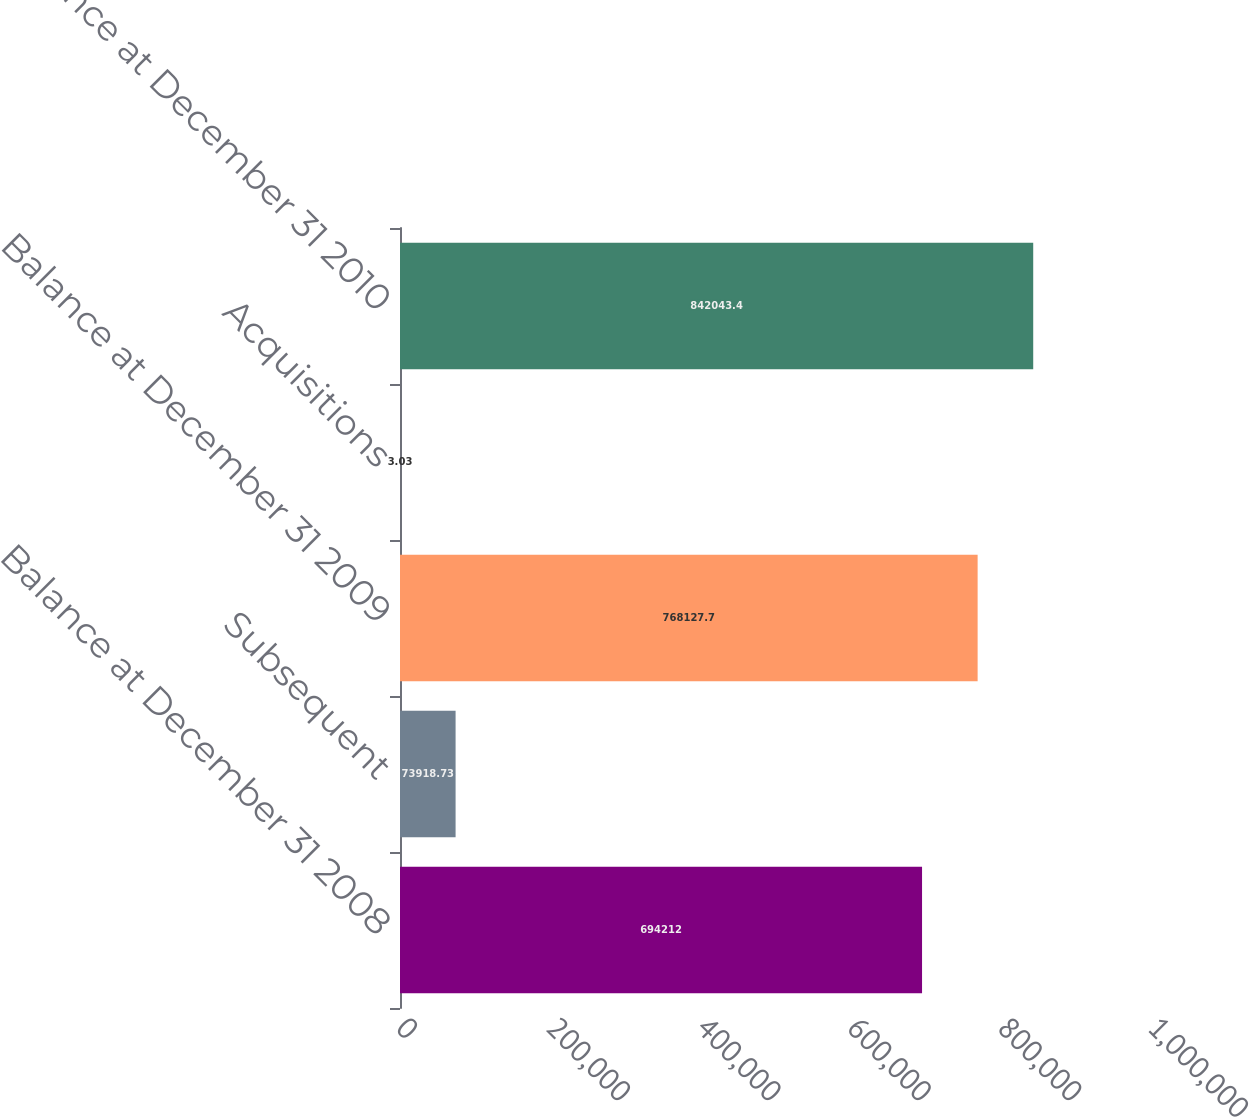Convert chart to OTSL. <chart><loc_0><loc_0><loc_500><loc_500><bar_chart><fcel>Balance at December 31 2008<fcel>Subsequent<fcel>Balance at December 31 2009<fcel>Acquisitions<fcel>Balance at December 31 2010<nl><fcel>694212<fcel>73918.7<fcel>768128<fcel>3.03<fcel>842043<nl></chart> 